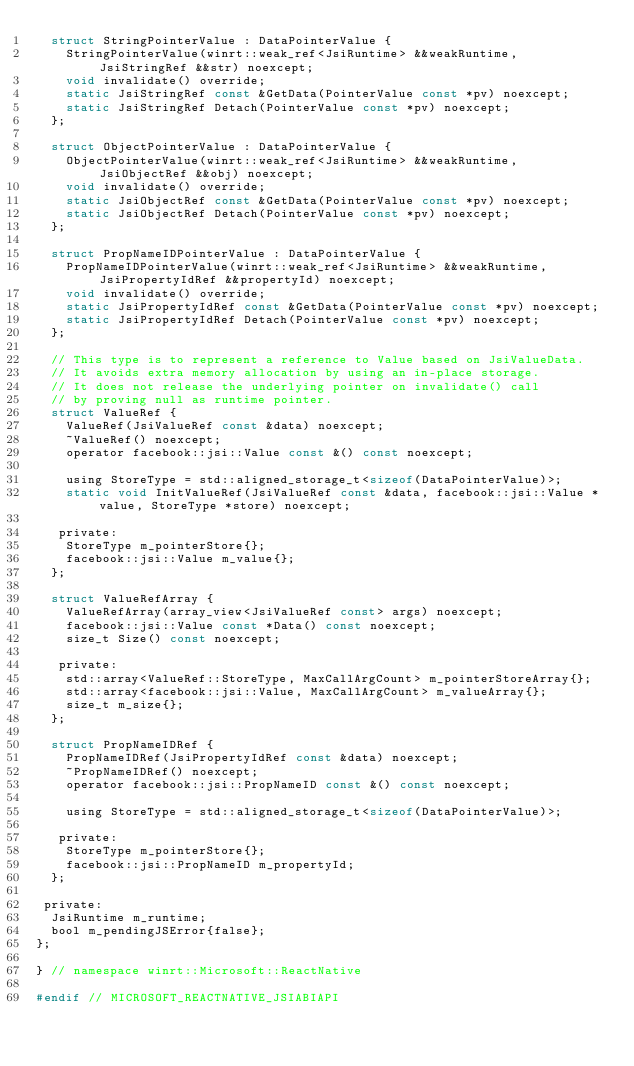<code> <loc_0><loc_0><loc_500><loc_500><_C_>  struct StringPointerValue : DataPointerValue {
    StringPointerValue(winrt::weak_ref<JsiRuntime> &&weakRuntime, JsiStringRef &&str) noexcept;
    void invalidate() override;
    static JsiStringRef const &GetData(PointerValue const *pv) noexcept;
    static JsiStringRef Detach(PointerValue const *pv) noexcept;
  };

  struct ObjectPointerValue : DataPointerValue {
    ObjectPointerValue(winrt::weak_ref<JsiRuntime> &&weakRuntime, JsiObjectRef &&obj) noexcept;
    void invalidate() override;
    static JsiObjectRef const &GetData(PointerValue const *pv) noexcept;
    static JsiObjectRef Detach(PointerValue const *pv) noexcept;
  };

  struct PropNameIDPointerValue : DataPointerValue {
    PropNameIDPointerValue(winrt::weak_ref<JsiRuntime> &&weakRuntime, JsiPropertyIdRef &&propertyId) noexcept;
    void invalidate() override;
    static JsiPropertyIdRef const &GetData(PointerValue const *pv) noexcept;
    static JsiPropertyIdRef Detach(PointerValue const *pv) noexcept;
  };

  // This type is to represent a reference to Value based on JsiValueData.
  // It avoids extra memory allocation by using an in-place storage.
  // It does not release the underlying pointer on invalidate() call
  // by proving null as runtime pointer.
  struct ValueRef {
    ValueRef(JsiValueRef const &data) noexcept;
    ~ValueRef() noexcept;
    operator facebook::jsi::Value const &() const noexcept;

    using StoreType = std::aligned_storage_t<sizeof(DataPointerValue)>;
    static void InitValueRef(JsiValueRef const &data, facebook::jsi::Value *value, StoreType *store) noexcept;

   private:
    StoreType m_pointerStore{};
    facebook::jsi::Value m_value{};
  };

  struct ValueRefArray {
    ValueRefArray(array_view<JsiValueRef const> args) noexcept;
    facebook::jsi::Value const *Data() const noexcept;
    size_t Size() const noexcept;

   private:
    std::array<ValueRef::StoreType, MaxCallArgCount> m_pointerStoreArray{};
    std::array<facebook::jsi::Value, MaxCallArgCount> m_valueArray{};
    size_t m_size{};
  };

  struct PropNameIDRef {
    PropNameIDRef(JsiPropertyIdRef const &data) noexcept;
    ~PropNameIDRef() noexcept;
    operator facebook::jsi::PropNameID const &() const noexcept;

    using StoreType = std::aligned_storage_t<sizeof(DataPointerValue)>;

   private:
    StoreType m_pointerStore{};
    facebook::jsi::PropNameID m_propertyId;
  };

 private:
  JsiRuntime m_runtime;
  bool m_pendingJSError{false};
};

} // namespace winrt::Microsoft::ReactNative

#endif // MICROSOFT_REACTNATIVE_JSIABIAPI
</code> 